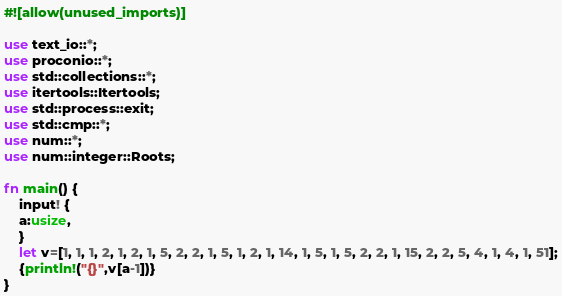<code> <loc_0><loc_0><loc_500><loc_500><_Rust_>#![allow(unused_imports)]

use text_io::*;
use proconio::*;
use std::collections::*;
use itertools::Itertools;
use std::process::exit;
use std::cmp::*;
use num::*;
use num::integer::Roots;

fn main() {
    input! {
    a:usize,
    }
    let v=[1, 1, 1, 2, 1, 2, 1, 5, 2, 2, 1, 5, 1, 2, 1, 14, 1, 5, 1, 5, 2, 2, 1, 15, 2, 2, 5, 4, 1, 4, 1, 51];
    {println!("{}",v[a-1])}
}</code> 